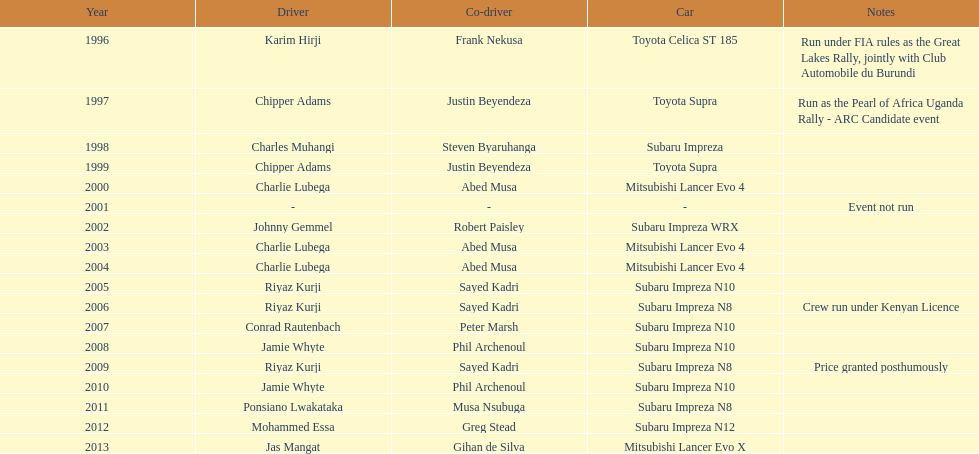How many times was charlie lubega a driver? 3. 